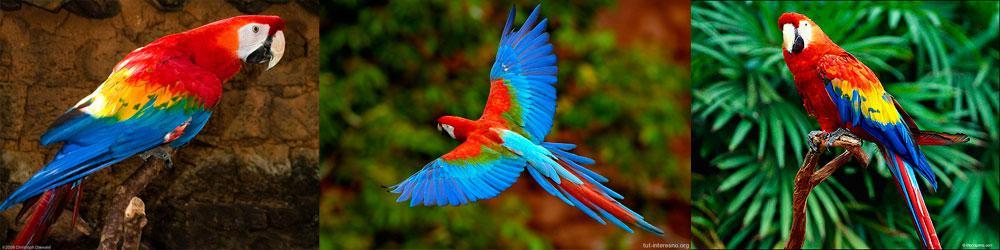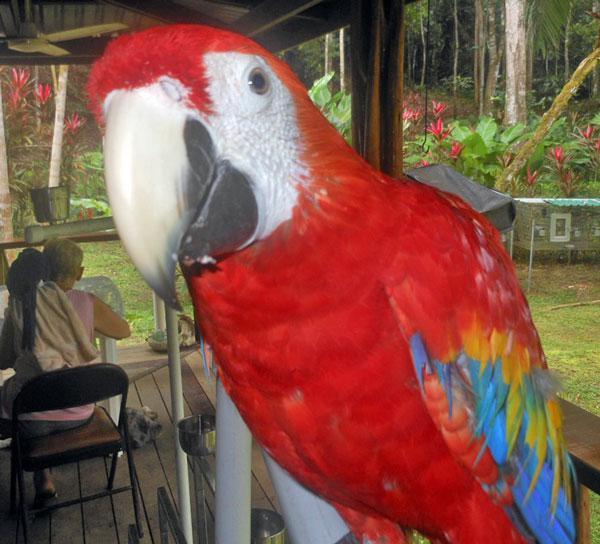The first image is the image on the left, the second image is the image on the right. For the images shown, is this caption "There are three birds in total" true? Answer yes or no. No. 